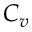Convert formula to latex. <formula><loc_0><loc_0><loc_500><loc_500>C _ { v }</formula> 